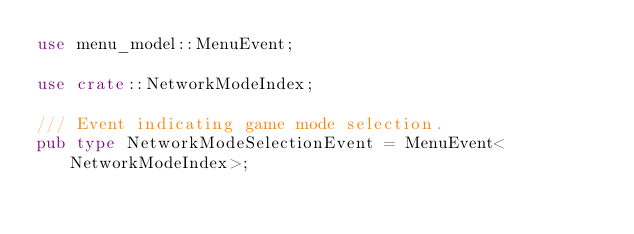<code> <loc_0><loc_0><loc_500><loc_500><_Rust_>use menu_model::MenuEvent;

use crate::NetworkModeIndex;

/// Event indicating game mode selection.
pub type NetworkModeSelectionEvent = MenuEvent<NetworkModeIndex>;
</code> 